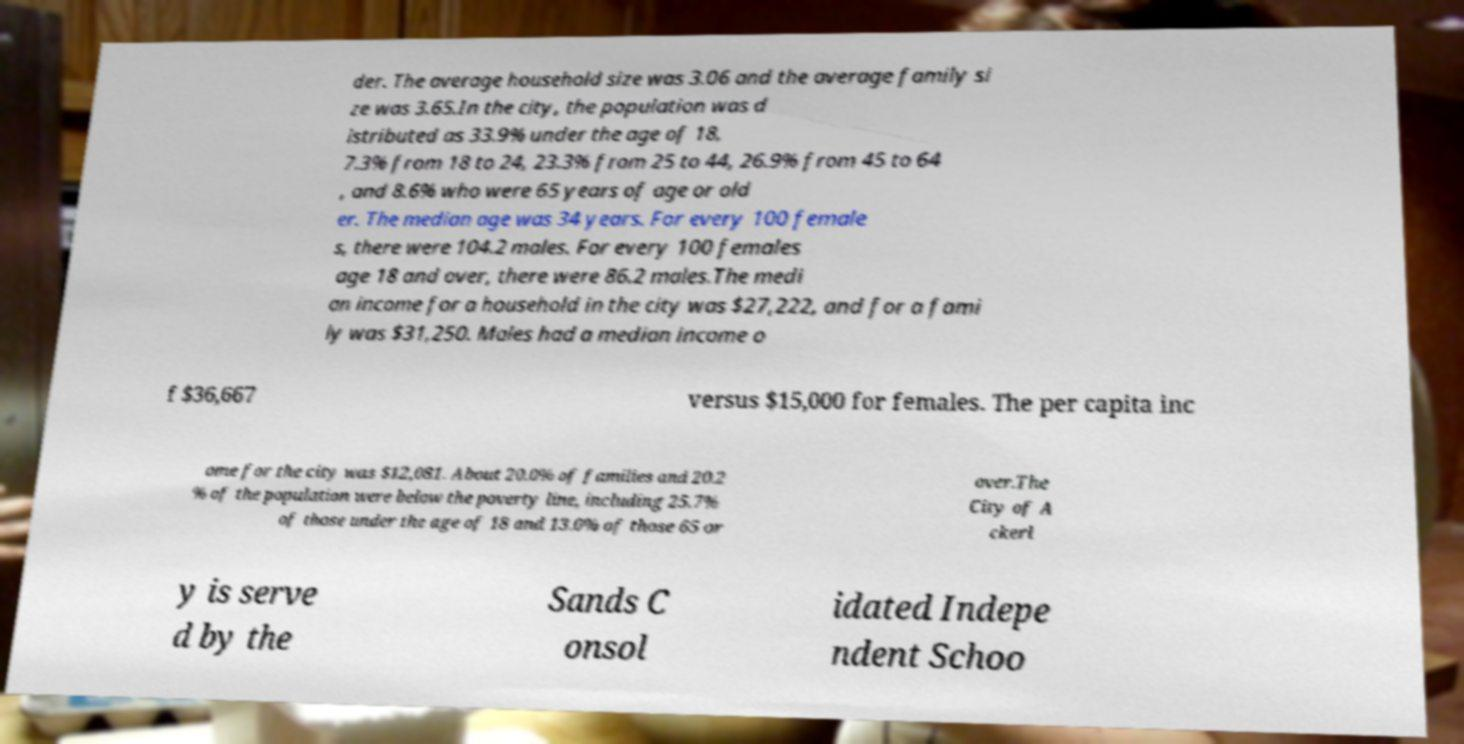Please identify and transcribe the text found in this image. der. The average household size was 3.06 and the average family si ze was 3.65.In the city, the population was d istributed as 33.9% under the age of 18, 7.3% from 18 to 24, 23.3% from 25 to 44, 26.9% from 45 to 64 , and 8.6% who were 65 years of age or old er. The median age was 34 years. For every 100 female s, there were 104.2 males. For every 100 females age 18 and over, there were 86.2 males.The medi an income for a household in the city was $27,222, and for a fami ly was $31,250. Males had a median income o f $36,667 versus $15,000 for females. The per capita inc ome for the city was $12,081. About 20.0% of families and 20.2 % of the population were below the poverty line, including 25.7% of those under the age of 18 and 13.0% of those 65 or over.The City of A ckerl y is serve d by the Sands C onsol idated Indepe ndent Schoo 